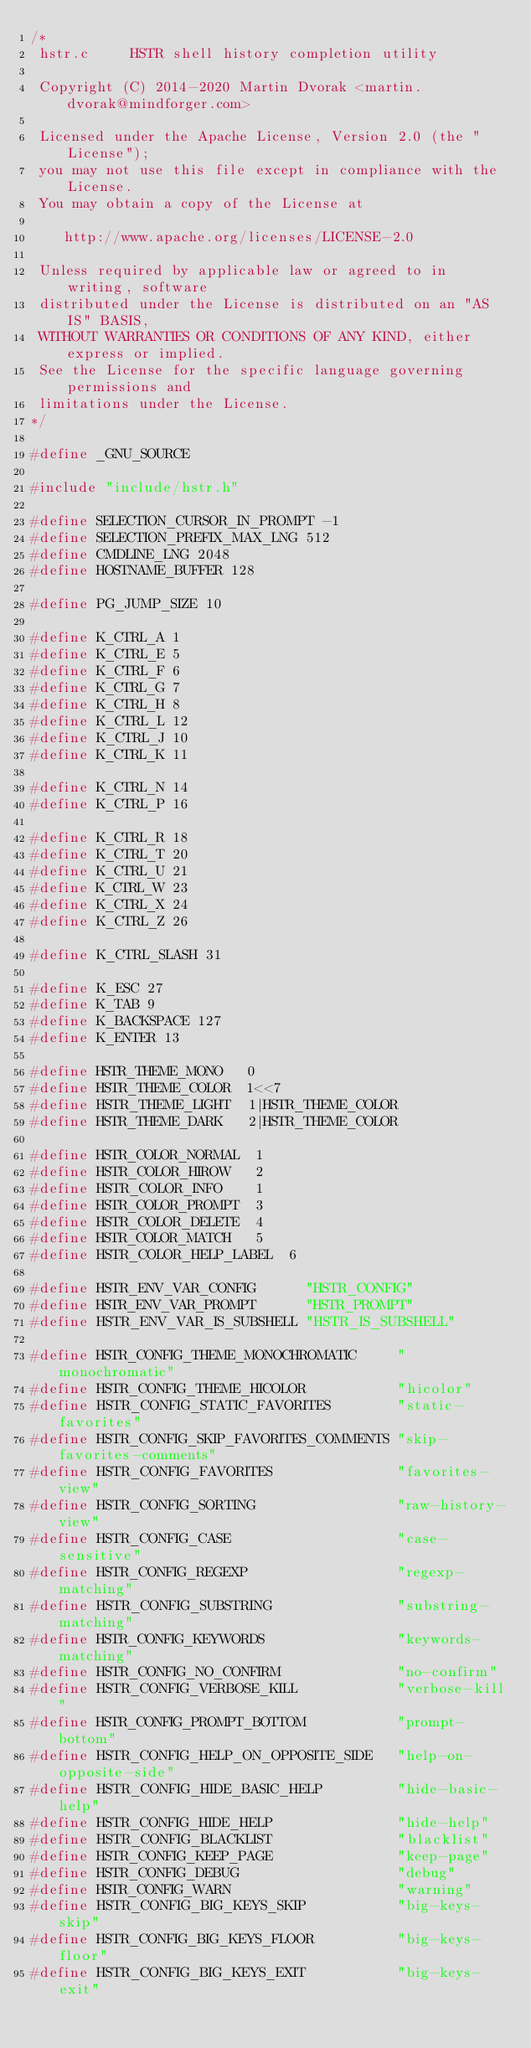Convert code to text. <code><loc_0><loc_0><loc_500><loc_500><_C_>/*
 hstr.c     HSTR shell history completion utility

 Copyright (C) 2014-2020 Martin Dvorak <martin.dvorak@mindforger.com>

 Licensed under the Apache License, Version 2.0 (the "License");
 you may not use this file except in compliance with the License.
 You may obtain a copy of the License at

    http://www.apache.org/licenses/LICENSE-2.0

 Unless required by applicable law or agreed to in writing, software
 distributed under the License is distributed on an "AS IS" BASIS,
 WITHOUT WARRANTIES OR CONDITIONS OF ANY KIND, either express or implied.
 See the License for the specific language governing permissions and
 limitations under the License.
*/

#define _GNU_SOURCE

#include "include/hstr.h"

#define SELECTION_CURSOR_IN_PROMPT -1
#define SELECTION_PREFIX_MAX_LNG 512
#define CMDLINE_LNG 2048
#define HOSTNAME_BUFFER 128

#define PG_JUMP_SIZE 10

#define K_CTRL_A 1
#define K_CTRL_E 5
#define K_CTRL_F 6
#define K_CTRL_G 7
#define K_CTRL_H 8
#define K_CTRL_L 12
#define K_CTRL_J 10
#define K_CTRL_K 11

#define K_CTRL_N 14
#define K_CTRL_P 16

#define K_CTRL_R 18
#define K_CTRL_T 20
#define K_CTRL_U 21
#define K_CTRL_W 23
#define K_CTRL_X 24
#define K_CTRL_Z 26

#define K_CTRL_SLASH 31

#define K_ESC 27
#define K_TAB 9
#define K_BACKSPACE 127
#define K_ENTER 13

#define HSTR_THEME_MONO   0
#define HSTR_THEME_COLOR  1<<7
#define HSTR_THEME_LIGHT  1|HSTR_THEME_COLOR
#define HSTR_THEME_DARK   2|HSTR_THEME_COLOR

#define HSTR_COLOR_NORMAL  1
#define HSTR_COLOR_HIROW   2
#define HSTR_COLOR_INFO    1
#define HSTR_COLOR_PROMPT  3
#define HSTR_COLOR_DELETE  4
#define HSTR_COLOR_MATCH   5
#define HSTR_COLOR_HELP_LABEL  6

#define HSTR_ENV_VAR_CONFIG      "HSTR_CONFIG"
#define HSTR_ENV_VAR_PROMPT      "HSTR_PROMPT"
#define HSTR_ENV_VAR_IS_SUBSHELL "HSTR_IS_SUBSHELL"

#define HSTR_CONFIG_THEME_MONOCHROMATIC     "monochromatic"
#define HSTR_CONFIG_THEME_HICOLOR           "hicolor"
#define HSTR_CONFIG_STATIC_FAVORITES        "static-favorites"
#define HSTR_CONFIG_SKIP_FAVORITES_COMMENTS "skip-favorites-comments"
#define HSTR_CONFIG_FAVORITES               "favorites-view"
#define HSTR_CONFIG_SORTING                 "raw-history-view"
#define HSTR_CONFIG_CASE                    "case-sensitive"
#define HSTR_CONFIG_REGEXP                  "regexp-matching"
#define HSTR_CONFIG_SUBSTRING               "substring-matching"
#define HSTR_CONFIG_KEYWORDS                "keywords-matching"
#define HSTR_CONFIG_NO_CONFIRM              "no-confirm"
#define HSTR_CONFIG_VERBOSE_KILL            "verbose-kill"
#define HSTR_CONFIG_PROMPT_BOTTOM           "prompt-bottom"
#define HSTR_CONFIG_HELP_ON_OPPOSITE_SIDE   "help-on-opposite-side"
#define HSTR_CONFIG_HIDE_BASIC_HELP         "hide-basic-help"
#define HSTR_CONFIG_HIDE_HELP               "hide-help"
#define HSTR_CONFIG_BLACKLIST               "blacklist"
#define HSTR_CONFIG_KEEP_PAGE               "keep-page"
#define HSTR_CONFIG_DEBUG                   "debug"
#define HSTR_CONFIG_WARN                    "warning"
#define HSTR_CONFIG_BIG_KEYS_SKIP           "big-keys-skip"
#define HSTR_CONFIG_BIG_KEYS_FLOOR          "big-keys-floor"
#define HSTR_CONFIG_BIG_KEYS_EXIT           "big-keys-exit"</code> 